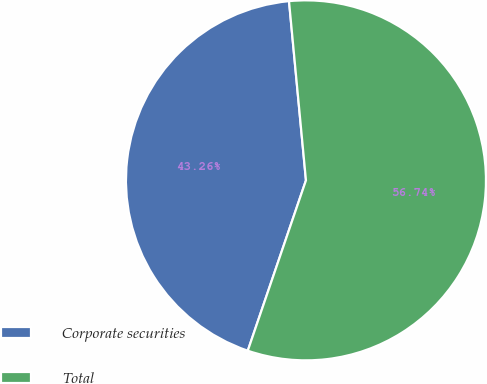Convert chart to OTSL. <chart><loc_0><loc_0><loc_500><loc_500><pie_chart><fcel>Corporate securities<fcel>Total<nl><fcel>43.26%<fcel>56.74%<nl></chart> 